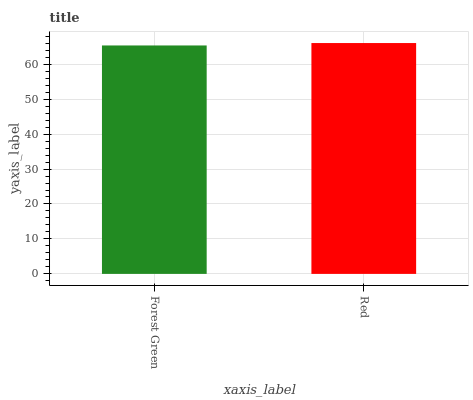Is Red the minimum?
Answer yes or no. No. Is Red greater than Forest Green?
Answer yes or no. Yes. Is Forest Green less than Red?
Answer yes or no. Yes. Is Forest Green greater than Red?
Answer yes or no. No. Is Red less than Forest Green?
Answer yes or no. No. Is Red the high median?
Answer yes or no. Yes. Is Forest Green the low median?
Answer yes or no. Yes. Is Forest Green the high median?
Answer yes or no. No. Is Red the low median?
Answer yes or no. No. 